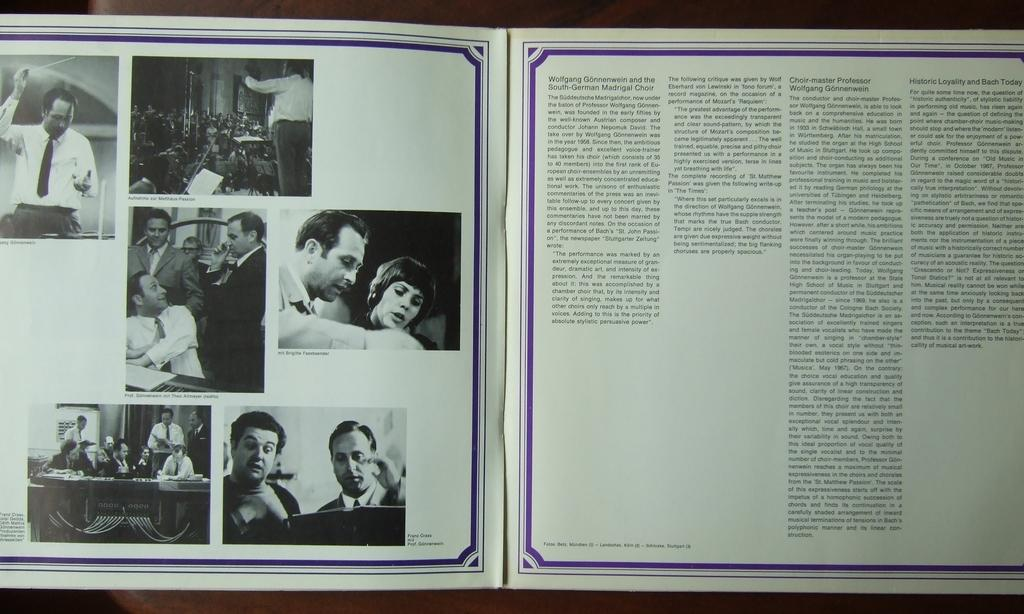<image>
Share a concise interpretation of the image provided. An information booklet for the South-German Madrigal Choir. 